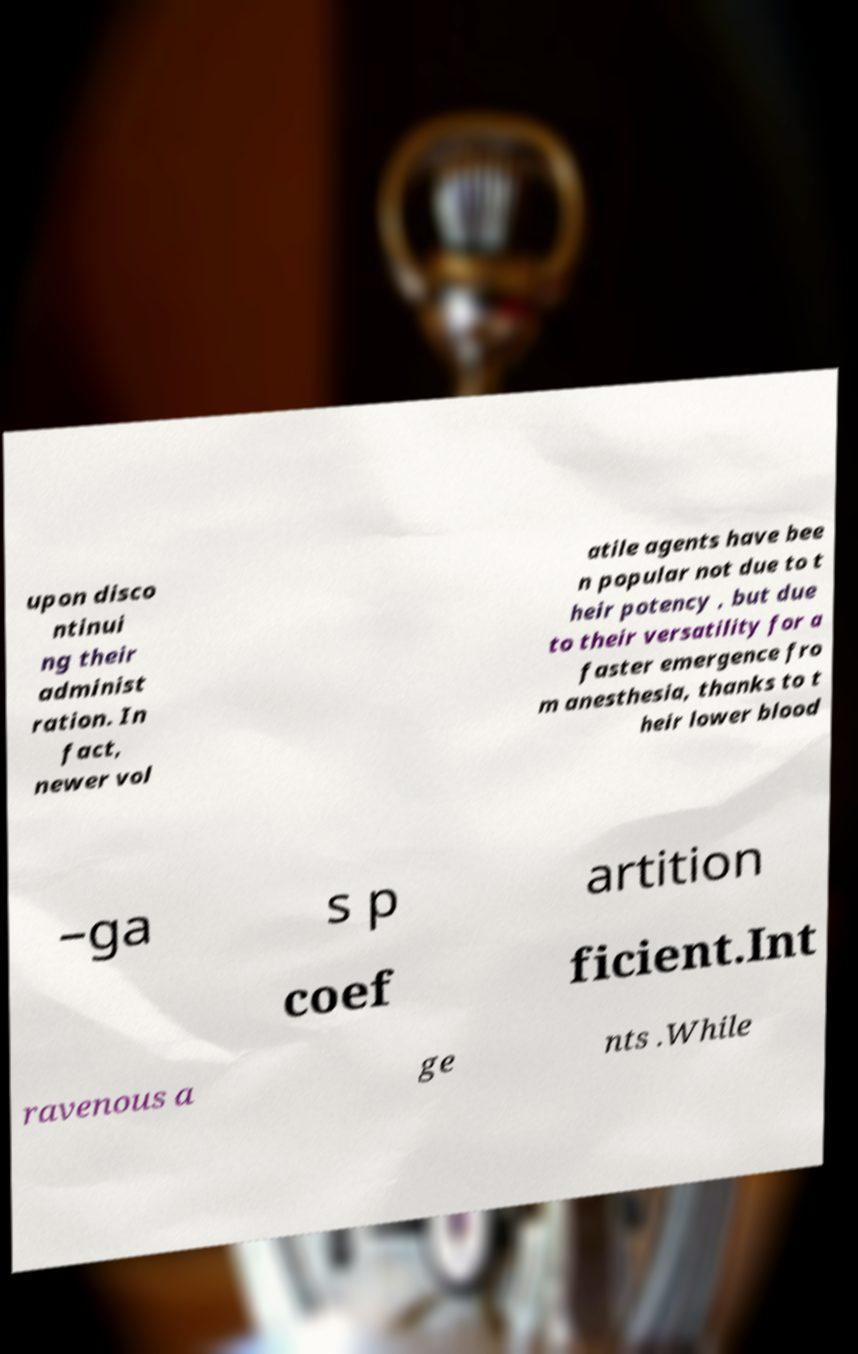Please identify and transcribe the text found in this image. upon disco ntinui ng their administ ration. In fact, newer vol atile agents have bee n popular not due to t heir potency , but due to their versatility for a faster emergence fro m anesthesia, thanks to t heir lower blood –ga s p artition coef ficient.Int ravenous a ge nts .While 